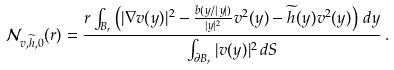<formula> <loc_0><loc_0><loc_500><loc_500>\mathcal { N } _ { v , \widetilde { h } , 0 } ( r ) = \frac { r \int _ { B _ { r } } \left ( | \nabla v ( y ) | ^ { 2 } - \frac { b ( y / | y | ) } { | y | ^ { 2 } } v ^ { 2 } ( y ) - \widetilde { h } ( y ) v ^ { 2 } ( y ) \right ) \, d y } { \int _ { \partial B _ { r } } | v ( y ) | ^ { 2 } \, d S } \, .</formula> 